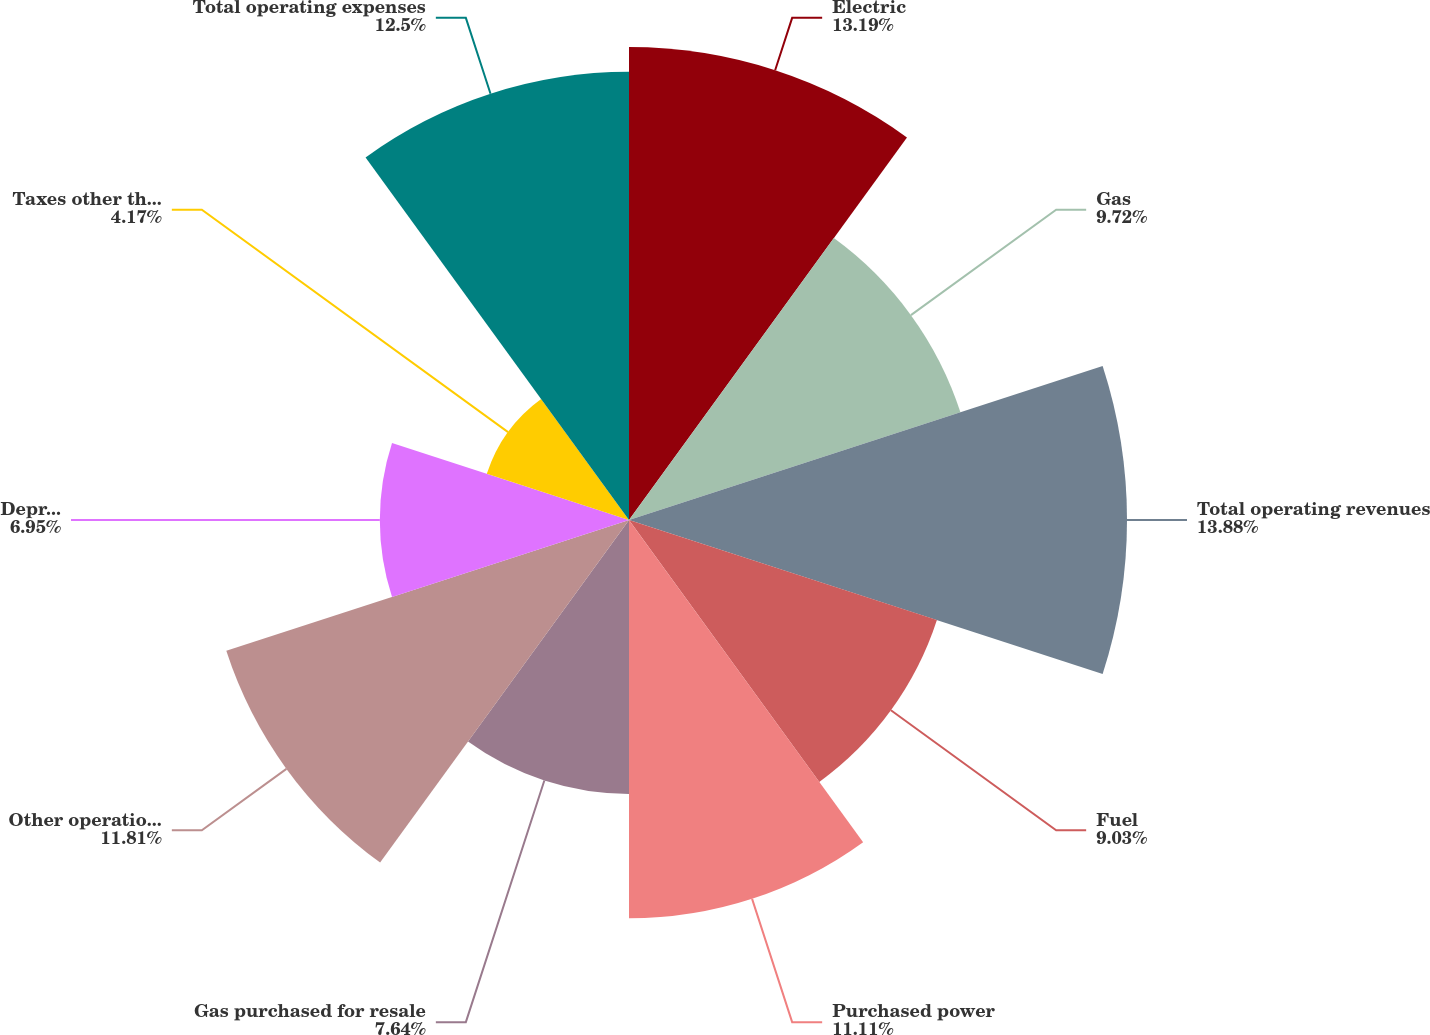Convert chart. <chart><loc_0><loc_0><loc_500><loc_500><pie_chart><fcel>Electric<fcel>Gas<fcel>Total operating revenues<fcel>Fuel<fcel>Purchased power<fcel>Gas purchased for resale<fcel>Other operations and<fcel>Depreciation and amortization<fcel>Taxes other than income taxes<fcel>Total operating expenses<nl><fcel>13.19%<fcel>9.72%<fcel>13.89%<fcel>9.03%<fcel>11.11%<fcel>7.64%<fcel>11.81%<fcel>6.95%<fcel>4.17%<fcel>12.5%<nl></chart> 